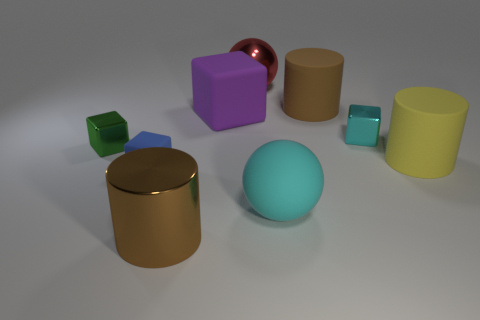Subtract all large brown rubber cylinders. How many cylinders are left? 2 Subtract all yellow spheres. How many brown cylinders are left? 2 Subtract 2 cylinders. How many cylinders are left? 1 Add 1 red spheres. How many objects exist? 10 Subtract all yellow cylinders. How many cylinders are left? 2 Subtract 0 purple cylinders. How many objects are left? 9 Subtract all cubes. How many objects are left? 5 Subtract all red cylinders. Subtract all cyan blocks. How many cylinders are left? 3 Subtract all large shiny cylinders. Subtract all cyan metal cylinders. How many objects are left? 8 Add 1 small green metallic objects. How many small green metallic objects are left? 2 